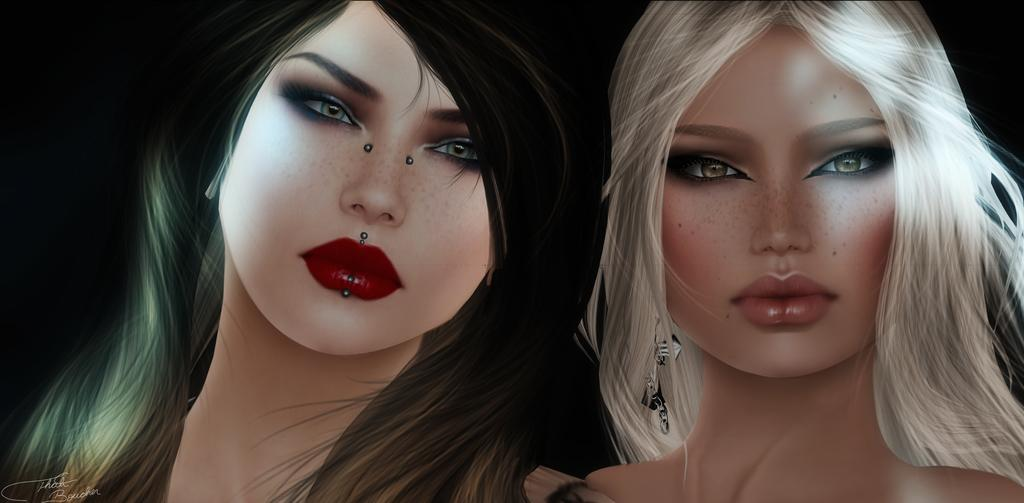What type of characters are present in the image? There are two cartoon characters in the image. Where are the cartoon characters located in the image? The cartoon characters are in the center of the image. What type of apparel is the cartoon character wearing while driving in the image? There is no cartoon character driving in the image, and no apparel can be seen on the characters. 